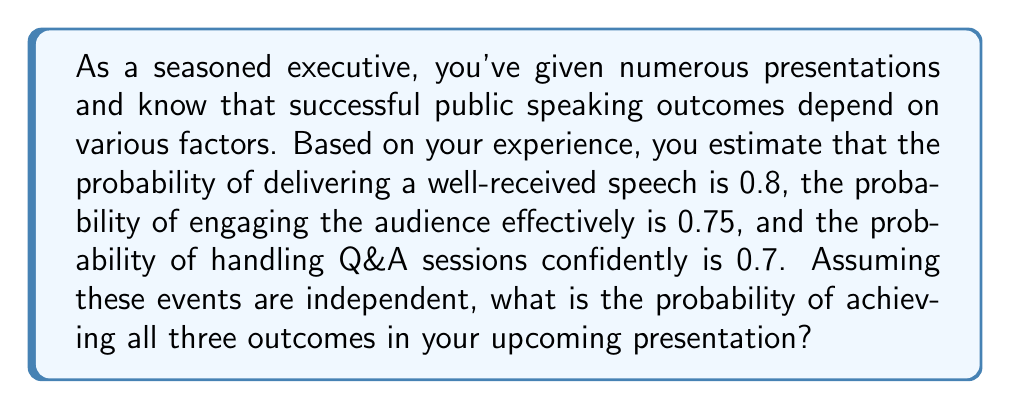Can you answer this question? To solve this problem, we need to use the multiplication rule for independent events. Since we're told that the events are independent, we can multiply their individual probabilities to find the probability of all events occurring together.

Let's define our events:
A: Delivering a well-received speech (P(A) = 0.8)
B: Engaging the audience effectively (P(B) = 0.75)
C: Handling Q&A sessions confidently (P(C) = 0.7)

We want to find P(A ∩ B ∩ C), the probability of all three events occurring.

For independent events, we have:

$$ P(A \cap B \cap C) = P(A) \cdot P(B) \cdot P(C) $$

Substituting the given probabilities:

$$ P(A \cap B \cap C) = 0.8 \cdot 0.75 \cdot 0.7 $$

Now, let's calculate:

$$ P(A \cap B \cap C) = 0.8 \cdot 0.75 \cdot 0.7 = 0.42 $$

Therefore, the probability of achieving all three outcomes in your upcoming presentation is 0.42 or 42%.
Answer: The probability of achieving all three successful public speaking outcomes is 0.42 or 42%. 